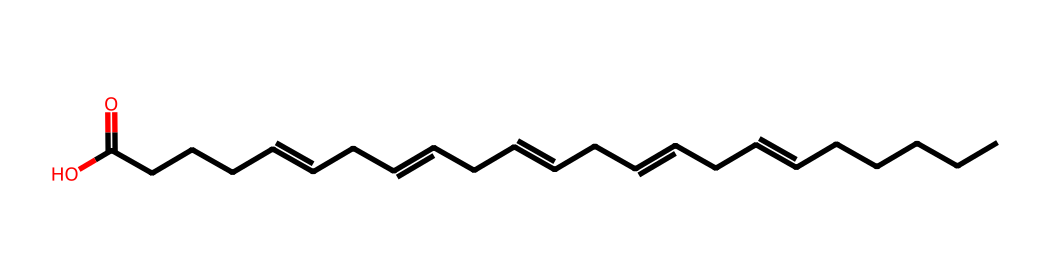What is the base structure of this compound? The provided SMILES representation indicates a long hydrocarbon chain with multiple double bonds, characteristic of unsaturated fatty acids. The molecule primarily consists of carbon and hydrogen atoms arranged in a typical fatty acid backbone.
Answer: fatty acid How many double bonds are present in this structure? To determine the number of double bonds, we can look for "=" symbols within the SMILES representation. Counting the "=" symbols reveals that there are 5 double bonds in this molecule.
Answer: five What functional group is present at the end of this molecule? The SMILES ends with "C(=O)O", indicating the presence of a carboxylic acid functional group (-COOH) at the end of the fatty acid. This functional group is responsible for its acidity.
Answer: carboxylic acid How many carbon atoms are in this fatty acid? By counting the "C" characters in the SMILES representation, we find there are 22 carbon atoms in total. Each "C" character corresponds to a carbon atom in the chain.
Answer: twenty-two Is this compound saturated or unsaturated? The presence of multiple double bonds in the structure, as evidenced by the "=" signs, categorizes this fatty acid as unsaturated. Saturated fatty acids contain only single bonds between carbon atoms.
Answer: unsaturated What type of coordination compounds could this fatty acid form? While fatty acids are not typically classified as coordination compounds, they can form complexes with metal ions, potentially acting as ligands due to the presence of the carboxylic acid group. The carboxylate portion can bind with metal ions while the hydrophobic tail may stabilize the complex.
Answer: ligands 